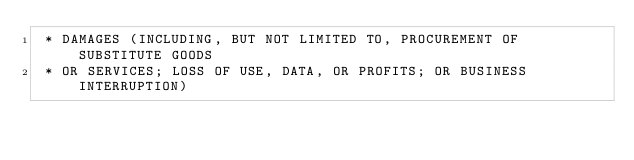Convert code to text. <code><loc_0><loc_0><loc_500><loc_500><_C_> * DAMAGES (INCLUDING, BUT NOT LIMITED TO, PROCUREMENT OF SUBSTITUTE GOODS
 * OR SERVICES; LOSS OF USE, DATA, OR PROFITS; OR BUSINESS INTERRUPTION)</code> 